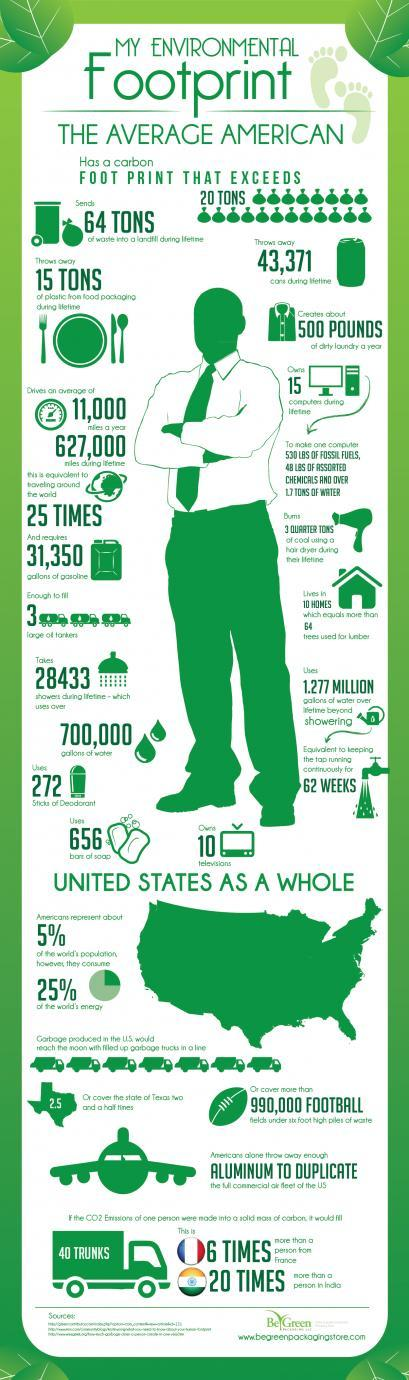What percentage of the world's population are not Americans?
Answer the question with a short phrase. 95% What percentage of the world's energy is not consumed by Americans? 75% 